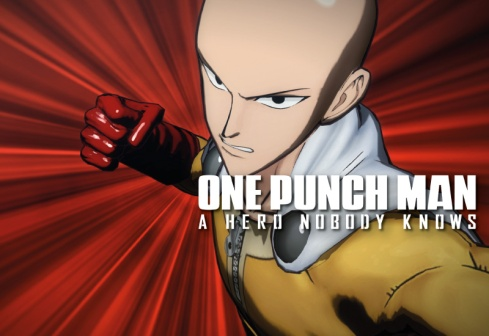How does the radial background contribute to the overall impact of the image? The radial background in the image significantly contributes to the overall impact by creating a sense of energy and movement. The gradient transition from black at the center to a bright red at the edges draws the viewer’s eye outward, amplifying the sense of motion and intensity around Saitama. This dynamic background enhances the dramatic atmosphere, highlighting the power and essence of Saitama’s character. It provides a visual cue that something extraordinary is occurring, emphasizing the action-packed nature of the scene and underscoring his heroism and unparalleled strength. Can you describe a scenario where this image might be used outside of the anime context? Certainly! This image of Saitama could be used in a motivational poster with a caption like 'Unleash Your Inner Strength' or 'Face Challenges with Determination.' The dynamic pose and intense background could inspire determination and confidence in various contexts, such as in a gym for fitness motivation or in an office to encourage perseverance and strong work ethics. If Saitama were to write a letter to his younger self, reflecting on his journey, what would it say? Dear Younger Me,

Looking back at our journey, I can’t help but smile at the path we've taken. In the beginning, I know it felt hopeless, training day in and day out, striving to become stronger. We questioned if it was worth it, but remember, every push-up, every run, every painful moment was building a hero inside us. We've faced our doubts, fought countless battles, and discovered the true essence of power. Yet, amidst all victories, the greatest lesson was not about our strength, but about finding purpose and meaning in being a hero.

Stay true to yourself, keep laughing at the irony of it all, and remember, the power we sought was always within us. Enjoy the journey, for the adventures will be legendary.

With confidence,
Saitama 